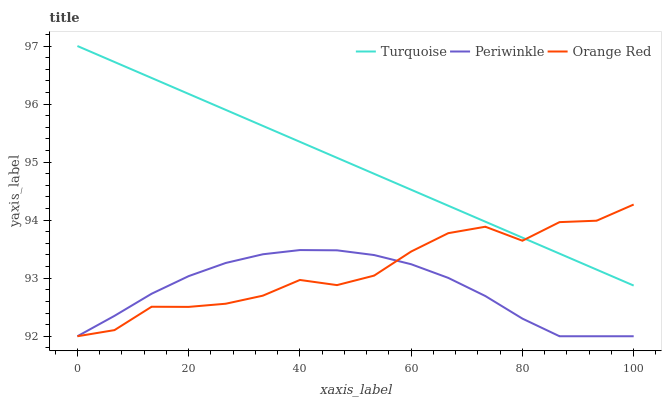Does Periwinkle have the minimum area under the curve?
Answer yes or no. Yes. Does Turquoise have the maximum area under the curve?
Answer yes or no. Yes. Does Orange Red have the minimum area under the curve?
Answer yes or no. No. Does Orange Red have the maximum area under the curve?
Answer yes or no. No. Is Turquoise the smoothest?
Answer yes or no. Yes. Is Orange Red the roughest?
Answer yes or no. Yes. Is Periwinkle the smoothest?
Answer yes or no. No. Is Periwinkle the roughest?
Answer yes or no. No. Does Periwinkle have the lowest value?
Answer yes or no. Yes. Does Turquoise have the highest value?
Answer yes or no. Yes. Does Orange Red have the highest value?
Answer yes or no. No. Is Periwinkle less than Turquoise?
Answer yes or no. Yes. Is Turquoise greater than Periwinkle?
Answer yes or no. Yes. Does Turquoise intersect Orange Red?
Answer yes or no. Yes. Is Turquoise less than Orange Red?
Answer yes or no. No. Is Turquoise greater than Orange Red?
Answer yes or no. No. Does Periwinkle intersect Turquoise?
Answer yes or no. No. 